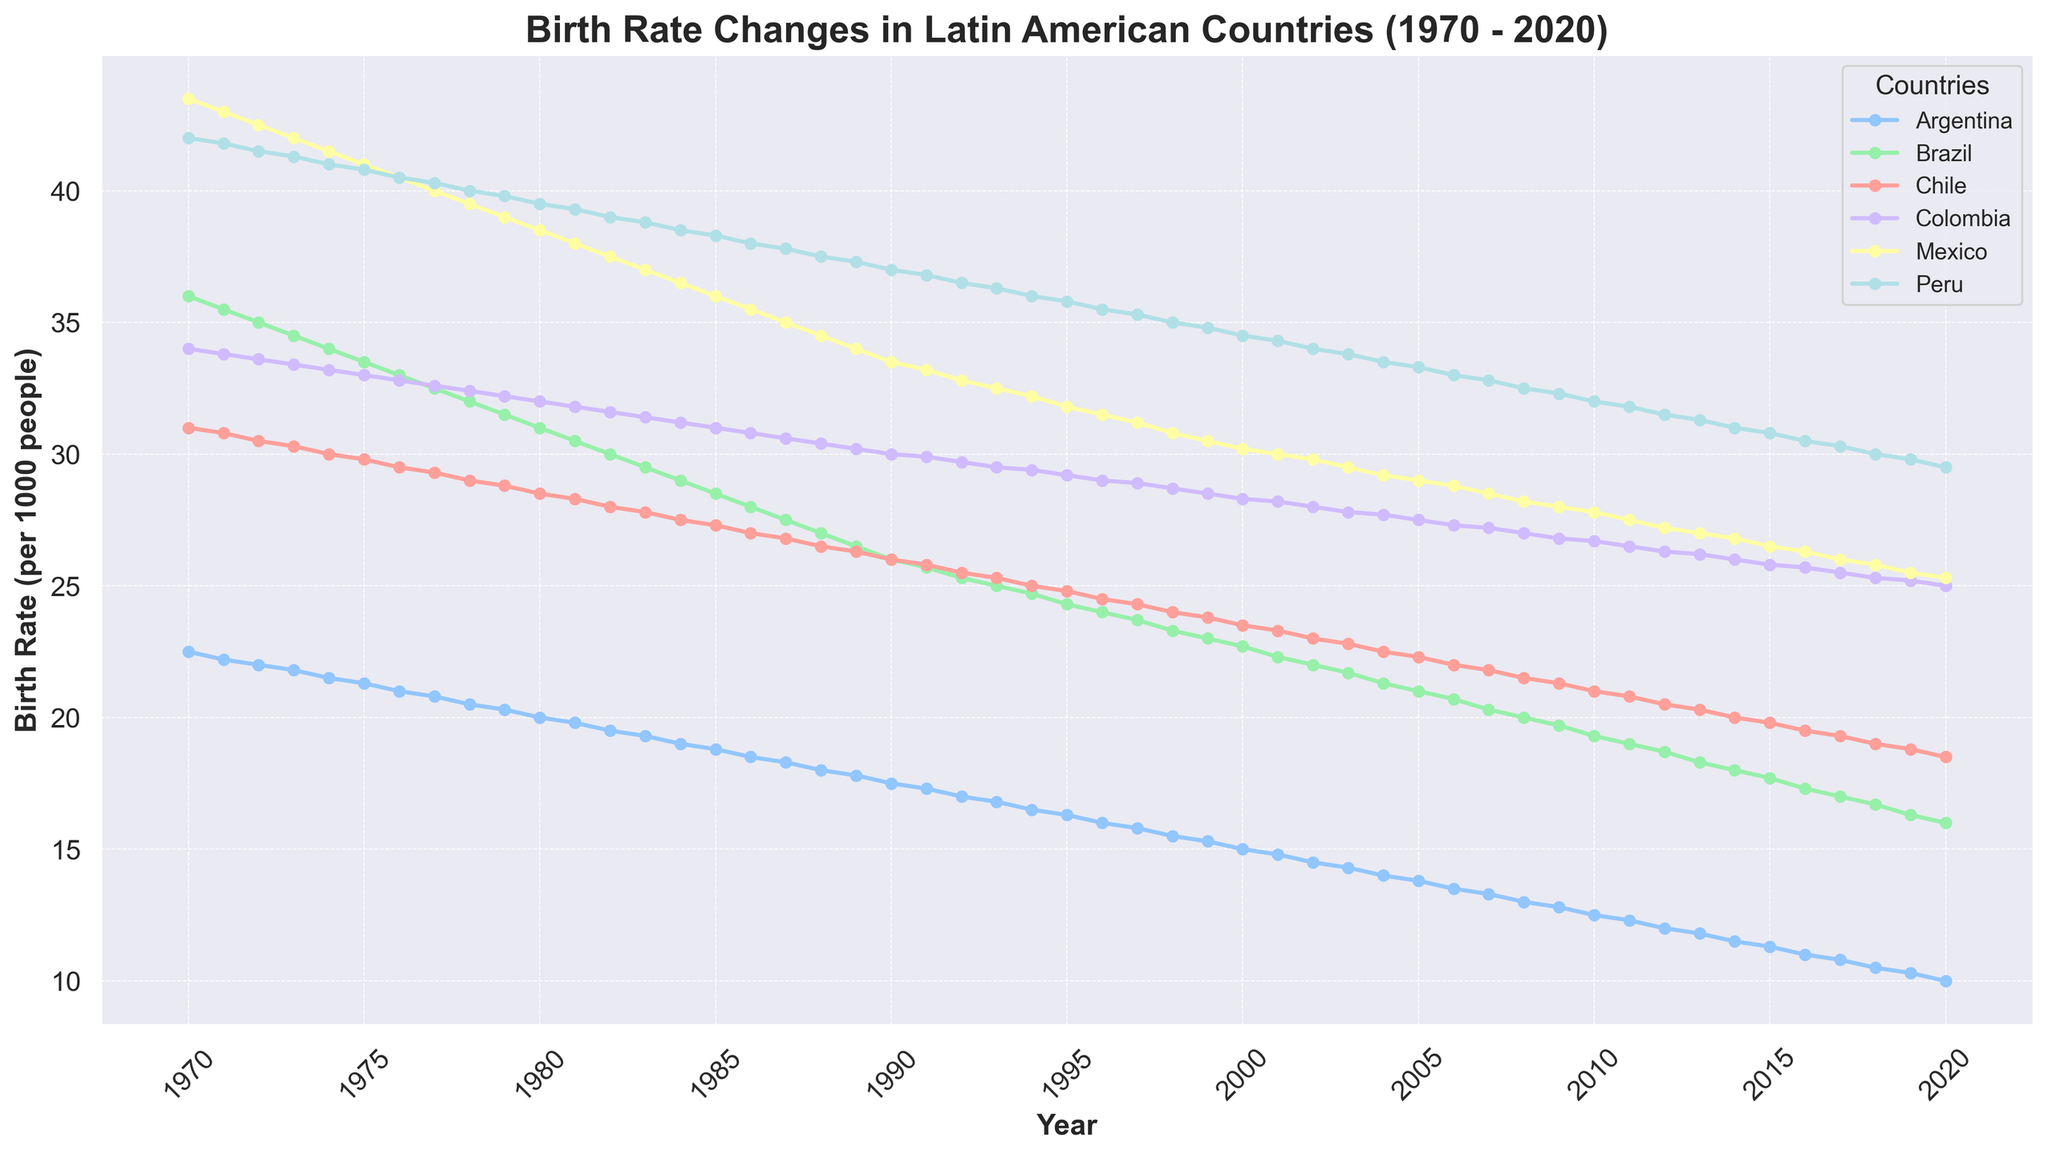Which country had the highest birth rate in 1970? Looking at the figure for the year 1970, we compare the birth rates for all the countries shown. Mexico had the highest birth rate.
Answer: Mexico How did the birth rate in Brazil change from 1970 to 2020? We look at the line representing Brazil in the figure. In 1970, the birth rate was 36.0, and by 2020, it had decreased to 16.0. The birth rate in Brazil significantly declined by 20 points over the 50-year period.
Answer: Decreased by 20 points Which two countries had the closest birth rates in 2000? By examining the figure for the year 2000, we compare the birth rates for all countries. Argentina and Chile had the closest birth rates at 15.0 and 23.5, respectively.
Answer: Argentina and Chile Which country showed the most significant decline from its peak birth rate to 2020? Evaluating the lines for all countries, Mexico had the most significant decline from its peak of 43.5 in 1970 to 25.3 in 2020, a decline of 18.2 points.
Answer: Mexico Between Argentina and Peru, which country had a lower birth rate in 1985? Referring to the figure for the year 1985, Argentina's birth rate was 18.8, and Peru's was 38.3. Argentina had the lower birth rate.
Answer: Argentina What is the average birth rate of Chile between 1970 and 2020? To calculate the average, we sum the birth rates of Chile for each year from 1970 to 2020 (31.0 + 30.8 + ... + 19.5 + 19.0 + ... + 18.5) and divide by the number of years (51 years). Upon calculation, we find the average.
Answer: Approximately 25.18 What was the trend in Colombia's birth rate between 1970 and 2020? Observing the line representing Colombia from 1970 to 2020, there is a consistent declining trend from 34.0 to 25.0.
Answer: Consistently decreased Which country had the least variation in its birth rate over the period? Reviewing the figure, we see that Argentina's birth rate varied the least because its line shows the smallest range of change compared to other countries.
Answer: Argentina In which year did Mexico's birth rate fall below 30 per 1000 people for the first time? Checking the line for Mexico, we identify the first year the birth rate was below 30. This occurred in 2005 when it was 29.0.
Answer: 2005 How many years did Peru maintain a birth rate above 40 per 1000 people? Examining the figure, we see that from 1970 to 1980, Peru’s birth rate was above 40. This spans 11 years.
Answer: 11 years 